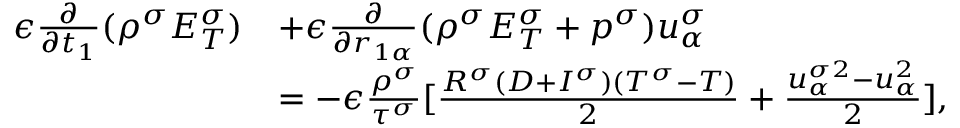<formula> <loc_0><loc_0><loc_500><loc_500>\begin{array} { r } { \begin{array} { r l } { \epsilon \frac { \partial } { \partial t _ { 1 } } ( \rho ^ { \sigma } E _ { T } ^ { \sigma } ) } & { + \epsilon \frac { \partial } { \partial r _ { 1 \alpha } } ( \rho ^ { \sigma } E _ { T } ^ { \sigma } + p ^ { \sigma } ) u _ { \alpha } ^ { \sigma } } \\ & { = - \epsilon \frac { \rho ^ { \sigma } } { \tau ^ { \sigma } } [ \frac { R ^ { \sigma } ( D + I ^ { \sigma } ) ( T ^ { \sigma } - T ) } { 2 } + \frac { u _ { \alpha } ^ { \sigma 2 } - u _ { \alpha } ^ { 2 } } { 2 } ] , } \end{array} } \end{array}</formula> 